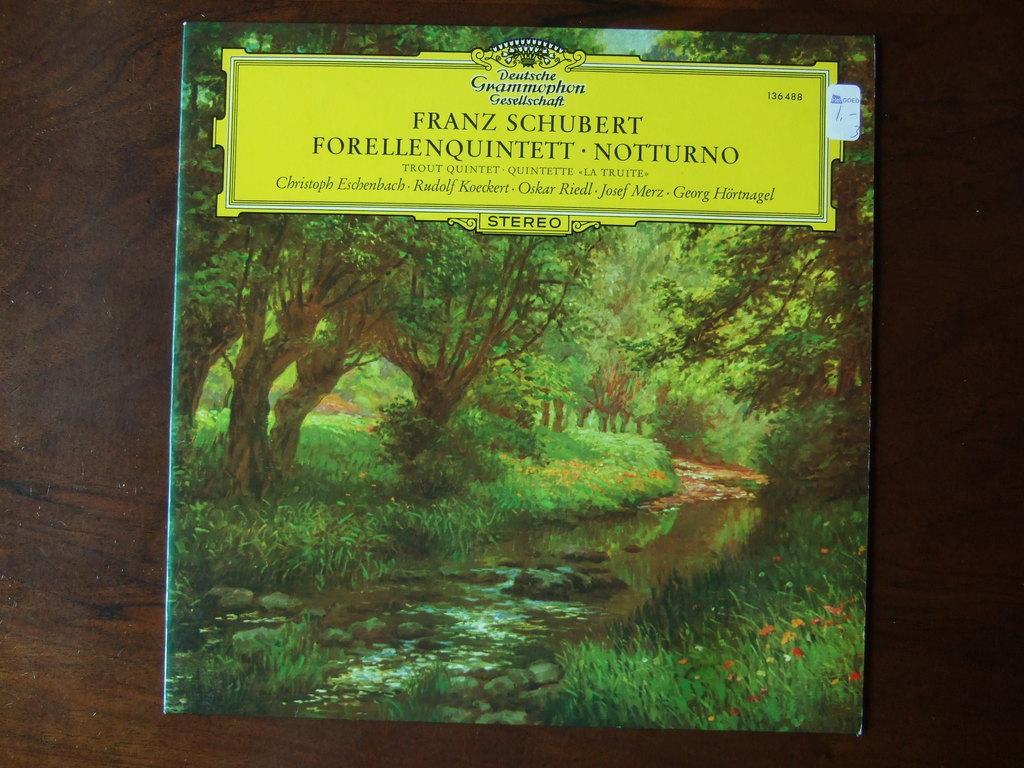Please provide a concise description of this image. In this image we can see the poster with the text, trees, grass, stones and also the water and flowers and the poster is placed on the wooden surface. 